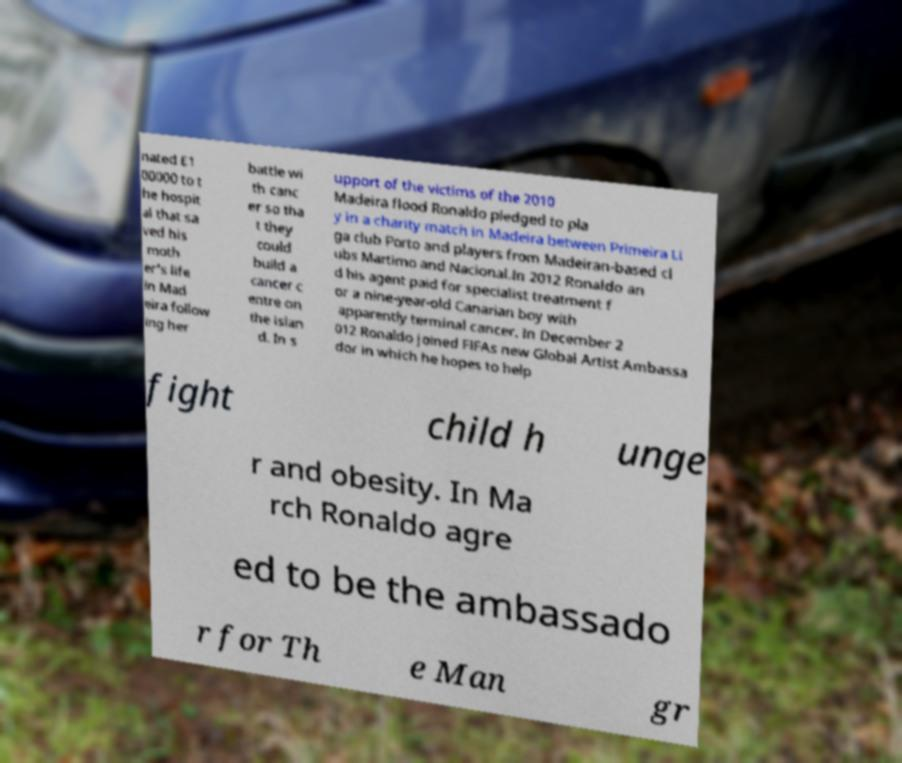Can you read and provide the text displayed in the image?This photo seems to have some interesting text. Can you extract and type it out for me? nated £1 00000 to t he hospit al that sa ved his moth er's life in Mad eira follow ing her battle wi th canc er so tha t they could build a cancer c entre on the islan d. In s upport of the victims of the 2010 Madeira flood Ronaldo pledged to pla y in a charity match in Madeira between Primeira Li ga club Porto and players from Madeiran-based cl ubs Martimo and Nacional.In 2012 Ronaldo an d his agent paid for specialist treatment f or a nine-year-old Canarian boy with apparently terminal cancer. In December 2 012 Ronaldo joined FIFAs new Global Artist Ambassa dor in which he hopes to help fight child h unge r and obesity. In Ma rch Ronaldo agre ed to be the ambassado r for Th e Man gr 